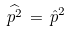<formula> <loc_0><loc_0><loc_500><loc_500>\widehat { p ^ { 2 } } \, = \, \hat { p } ^ { 2 }</formula> 